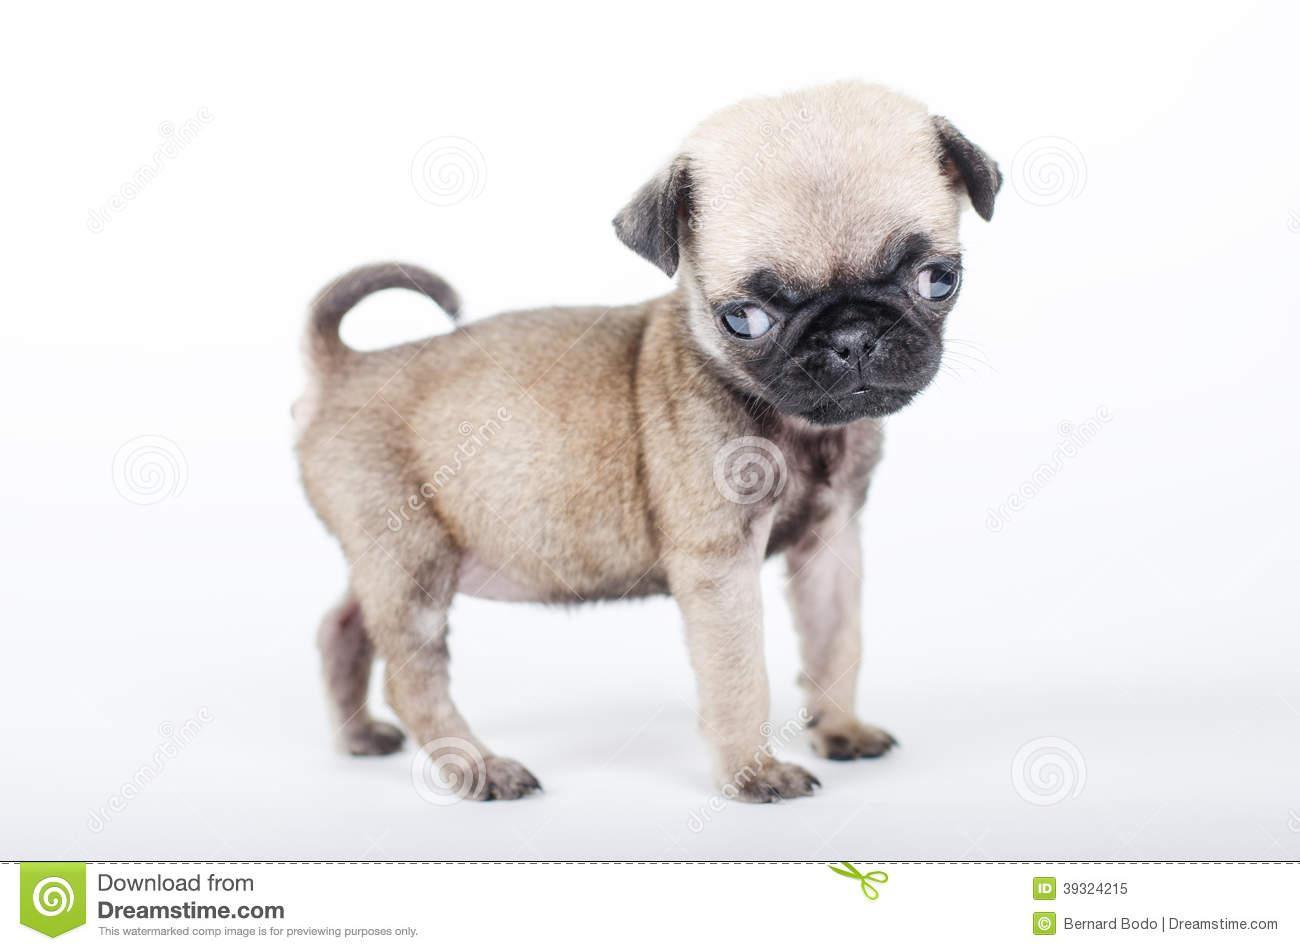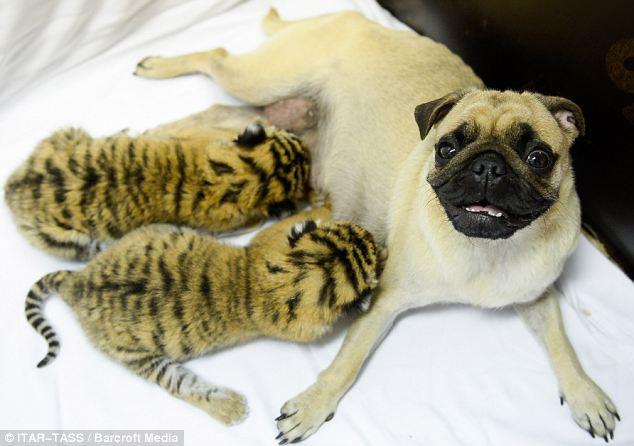The first image is the image on the left, the second image is the image on the right. Evaluate the accuracy of this statement regarding the images: "Two striped cats are nursing on a dog in one of the images.". Is it true? Answer yes or no. Yes. The first image is the image on the left, the second image is the image on the right. Considering the images on both sides, is "Two baby animals with tiger stripes are nursing a reclining pug dog in one image." valid? Answer yes or no. Yes. 